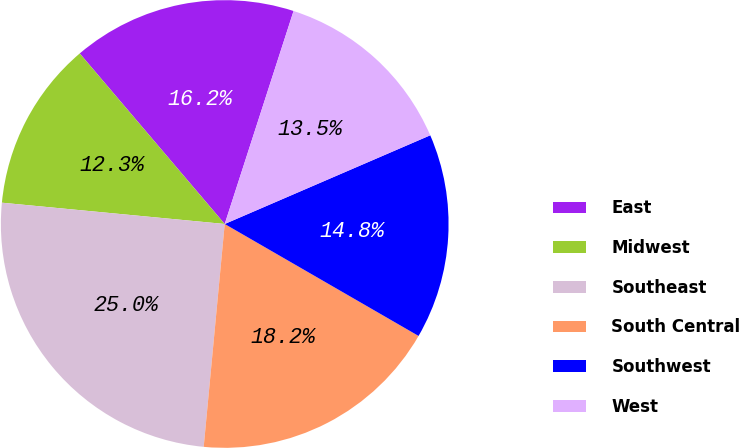Convert chart to OTSL. <chart><loc_0><loc_0><loc_500><loc_500><pie_chart><fcel>East<fcel>Midwest<fcel>Southeast<fcel>South Central<fcel>Southwest<fcel>West<nl><fcel>16.19%<fcel>12.27%<fcel>25.02%<fcel>18.16%<fcel>14.82%<fcel>13.54%<nl></chart> 